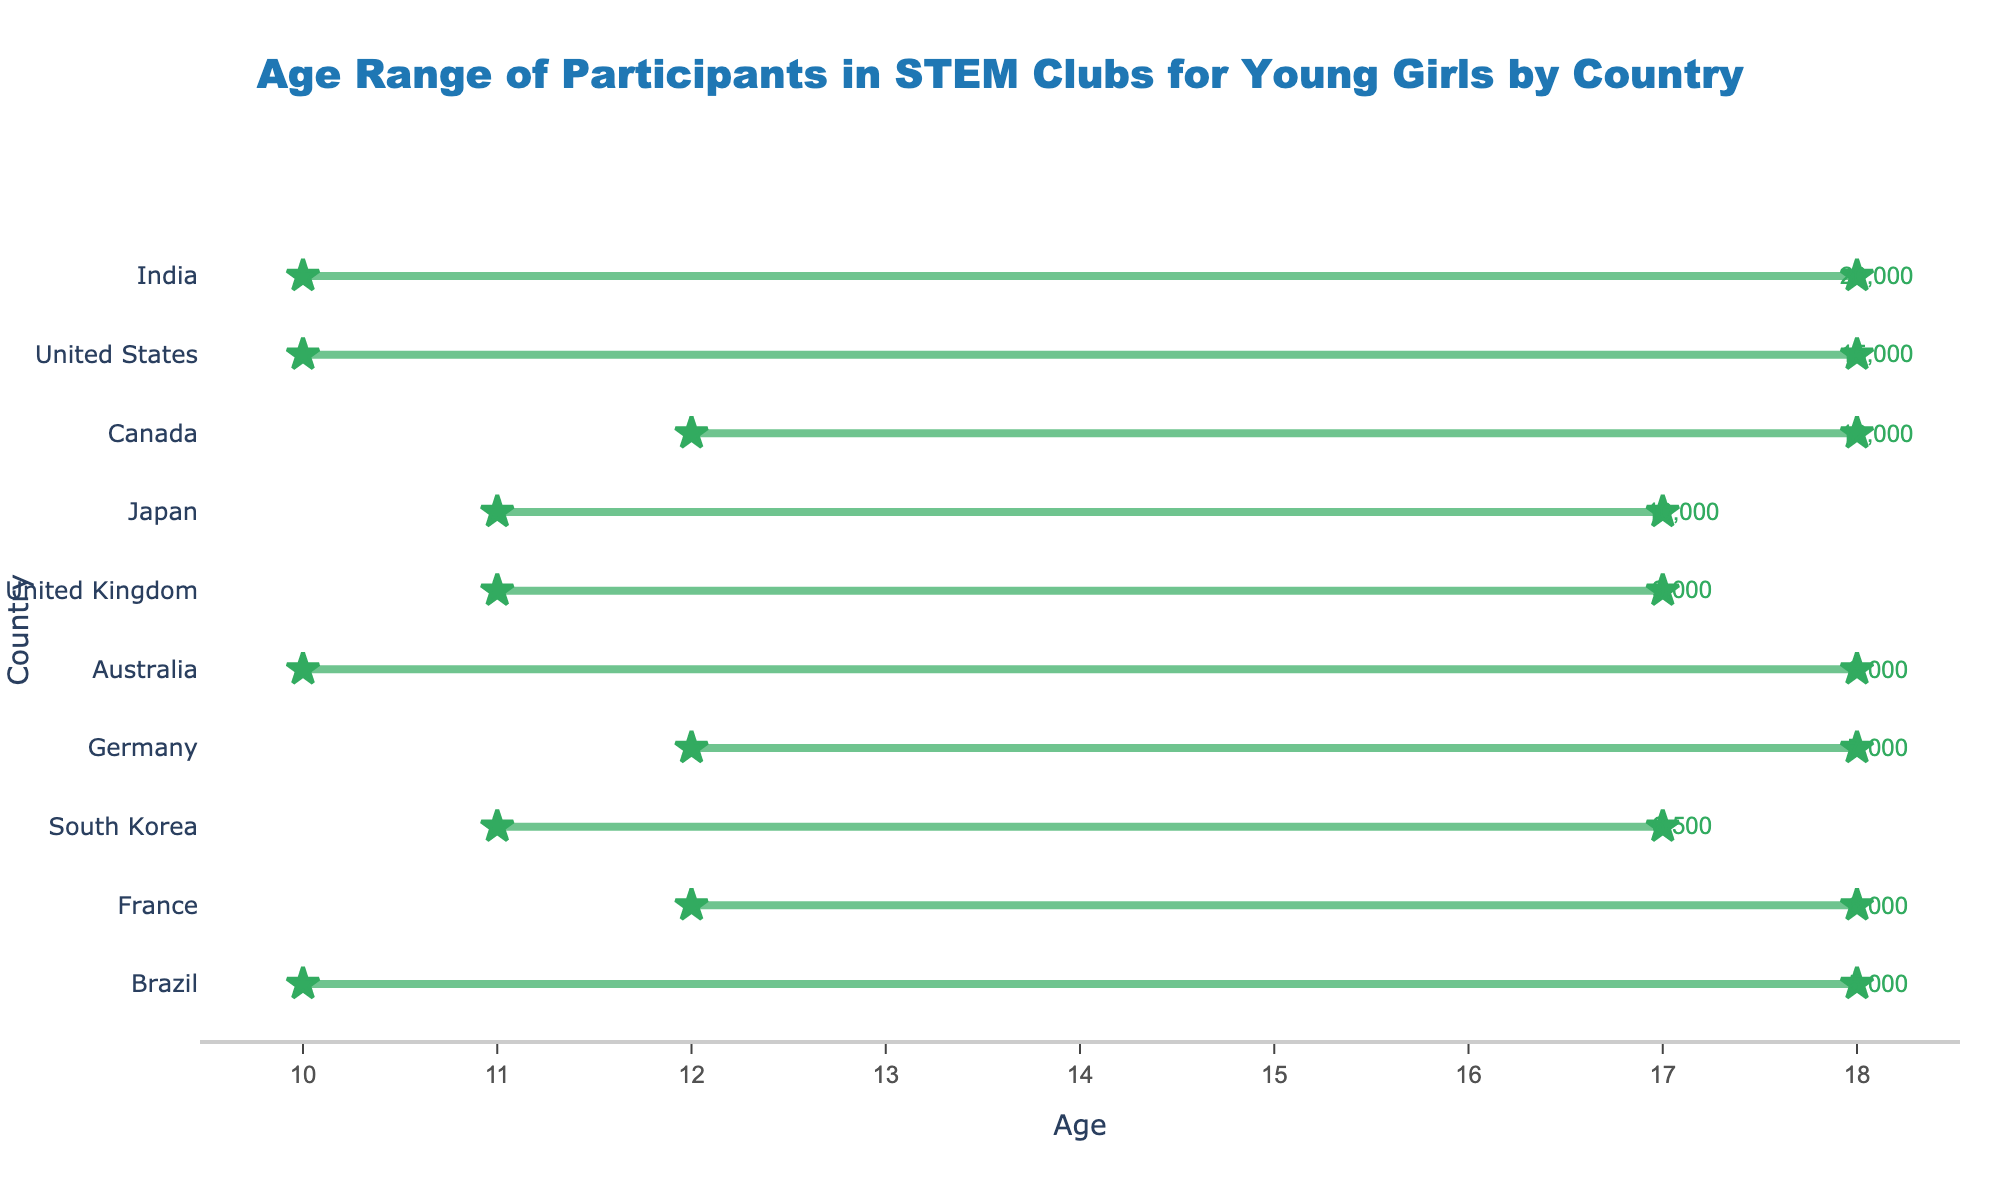What is the age range for participants in STEM clubs in the United States? The figure shows a line extending from the minimum age to the maximum age with markers at both ends, located next to the name of the country. For the United States, the line extends from 10 to 18 years.
Answer: 10-18 Which country has the highest number of participants in STEM clubs? The number of participants is shown next to the maximum age marker for each country. India has the highest number with 20,000 participants.
Answer: India How many countries have a maximum age of 18 for participants? The figure shows the maximum age markers for each country. By counting the countries with maximum age 18, we find four: United States, Canada, Australia, and India.
Answer: 4 What is the age range for participants in STEM clubs in Japan? The figure shows a line extending from the minimum age to the maximum age with markers at both ends, located next to the name of the country. For Japan, the line extends from 11 to 17 years.
Answer: 11-17 What is the difference in the number of participants between the country with the most and the country with the fewest participants? The figure shows the number of participants next to the maximum age marker for each country. India has the most participants (20,000) and Brazil has the fewest (5,000). The difference is 20,000 - 5,000 = 15,000.
Answer: 15,000 Which country has participants starting at age 12? The figure shows the minimum age markers for each country. By identifying these, we see that Canada, Germany, and France all have a minimum age of 12.
Answer: Canada, Germany, France What is the average number of participants across all countries? Add the number of participants for all countries and divide by the number of countries: (15000 + 12000 + 9000 + 8000 + 7000 + 20000 + 10000 + 6000 + 5000 + 6500) / 10 = 102,500 / 10 = 10,250.
Answer: 10,250 Which countries have a maximum age of 17 for participants? The figure shows the maximum age markers for each country. The United Kingdom, Japan, and South Korea have a maximum age of 17.
Answer: United Kingdom, Japan, South Korea What is the number of participants in STEM clubs for Australia? The figure shows the number of participants next to the maximum age marker for each country. Australia has 8,000 participants.
Answer: 8,000 